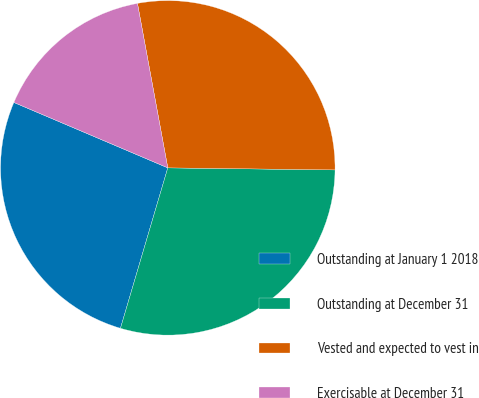<chart> <loc_0><loc_0><loc_500><loc_500><pie_chart><fcel>Outstanding at January 1 2018<fcel>Outstanding at December 31<fcel>Vested and expected to vest in<fcel>Exercisable at December 31<nl><fcel>26.83%<fcel>29.37%<fcel>28.1%<fcel>15.7%<nl></chart> 